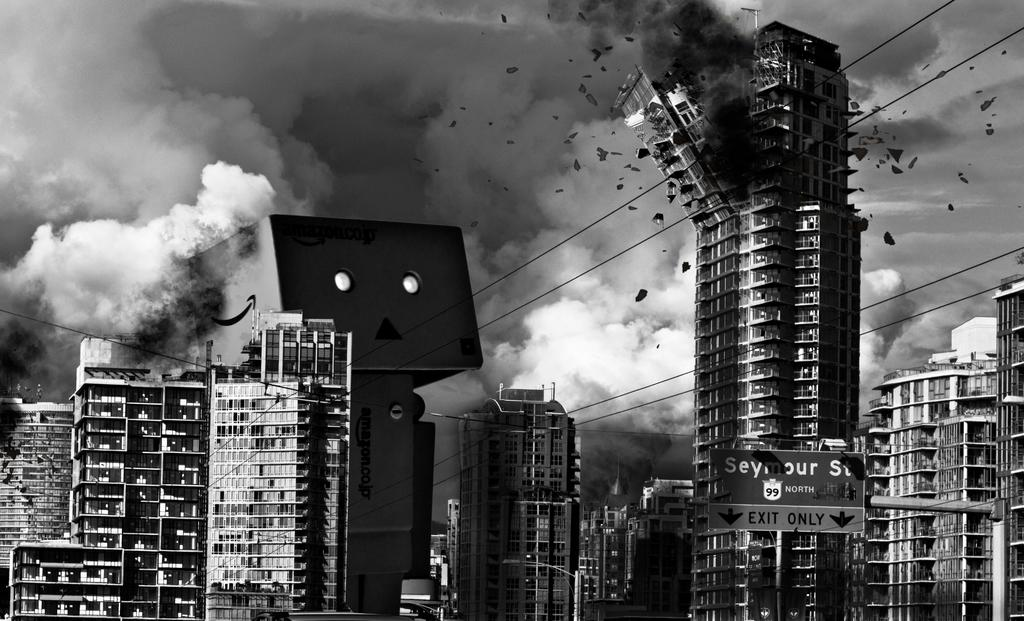What type of structures can be seen in the image? There are buildings in the image. What object is present to provide directions? There is a direction board in the image. What else can be seen in the image besides buildings and the direction board? There is a pole visible in the image. What can be observed in the background of the image? There is smoke visible in the background of the image. How many pins are attached to the pole in the image? There is no mention of pins in the image; the pole is not described in detail. What type of game is being played in the image? There is no indication of a game being played in the image; it features buildings, a direction board, a pole, and smoke in the background. 